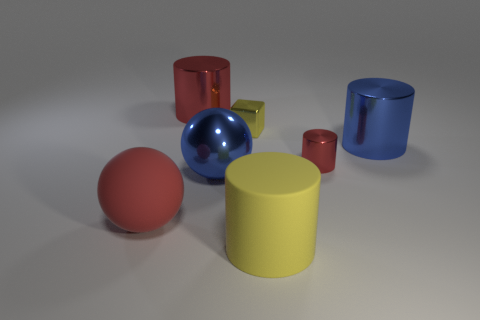Are there the same number of big red metallic things that are on the right side of the small cylinder and large purple cylinders?
Provide a succinct answer. Yes. Are there any other things that have the same size as the yellow matte cylinder?
Keep it short and to the point. Yes. What is the material of the small thing that is the same shape as the big yellow rubber thing?
Keep it short and to the point. Metal. What is the shape of the large blue metal thing on the left side of the big shiny object to the right of the yellow matte cylinder?
Your answer should be compact. Sphere. Is the small object right of the tiny cube made of the same material as the small cube?
Your response must be concise. Yes. Is the number of large blue shiny spheres that are in front of the yellow rubber cylinder the same as the number of blue things that are in front of the tiny yellow thing?
Provide a succinct answer. No. There is a large ball that is the same color as the small cylinder; what is its material?
Your answer should be compact. Rubber. What number of tiny yellow metal things are on the right side of the shiny object in front of the tiny red metal cylinder?
Give a very brief answer. 1. Do the metal cylinder that is to the left of the tiny red metal thing and the matte thing that is in front of the big red matte thing have the same color?
Your answer should be compact. No. What is the material of the other ball that is the same size as the rubber sphere?
Ensure brevity in your answer.  Metal. 